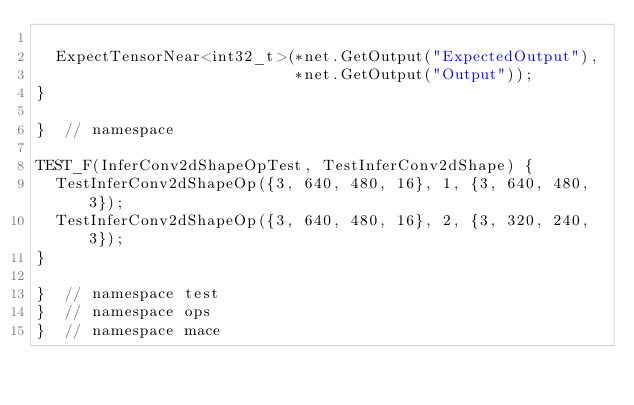Convert code to text. <code><loc_0><loc_0><loc_500><loc_500><_C++_>
  ExpectTensorNear<int32_t>(*net.GetOutput("ExpectedOutput"),
                            *net.GetOutput("Output"));
}

}  // namespace

TEST_F(InferConv2dShapeOpTest, TestInferConv2dShape) {
  TestInferConv2dShapeOp({3, 640, 480, 16}, 1, {3, 640, 480, 3});
  TestInferConv2dShapeOp({3, 640, 480, 16}, 2, {3, 320, 240, 3});
}

}  // namespace test
}  // namespace ops
}  // namespace mace
</code> 